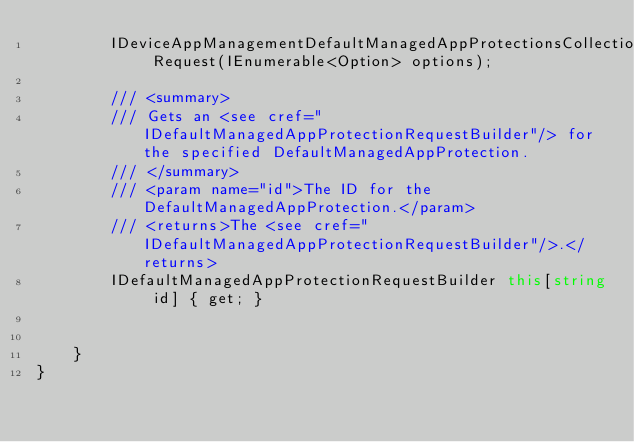<code> <loc_0><loc_0><loc_500><loc_500><_C#_>        IDeviceAppManagementDefaultManagedAppProtectionsCollectionRequest Request(IEnumerable<Option> options);

        /// <summary>
        /// Gets an <see cref="IDefaultManagedAppProtectionRequestBuilder"/> for the specified DefaultManagedAppProtection.
        /// </summary>
        /// <param name="id">The ID for the DefaultManagedAppProtection.</param>
        /// <returns>The <see cref="IDefaultManagedAppProtectionRequestBuilder"/>.</returns>
        IDefaultManagedAppProtectionRequestBuilder this[string id] { get; }

        
    }
}
</code> 